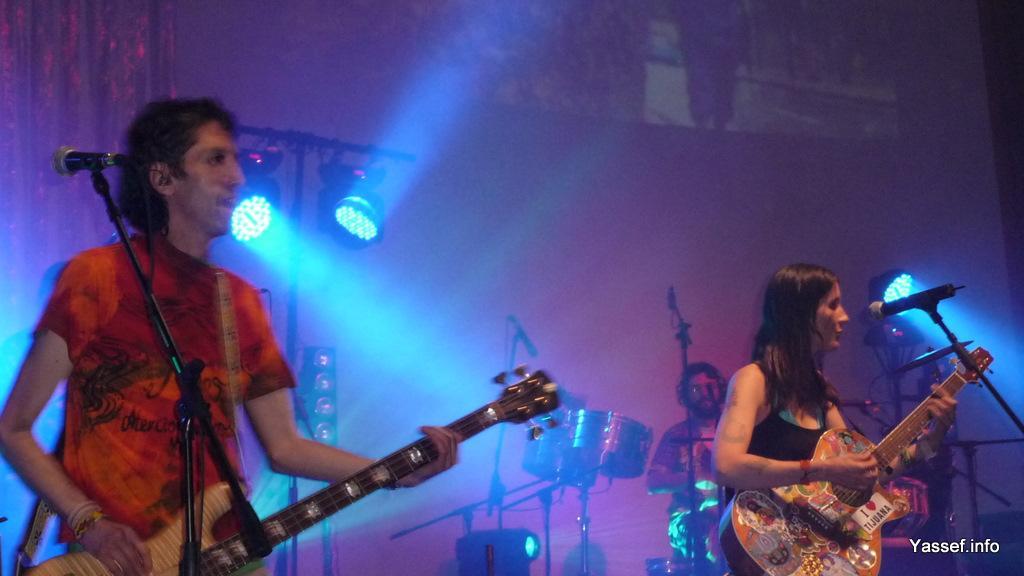Can you describe this image briefly? In this picture it seems like a stage performance the two persons are standing holding a guitar in their hand and there is a mic in front of the left corner person and the lady in the right corner is also singing holding a guitar in her hand in front of the mic and in the back ground i can see the drums and the person is hitting a drum. In the background i could see the lights focus lights. 